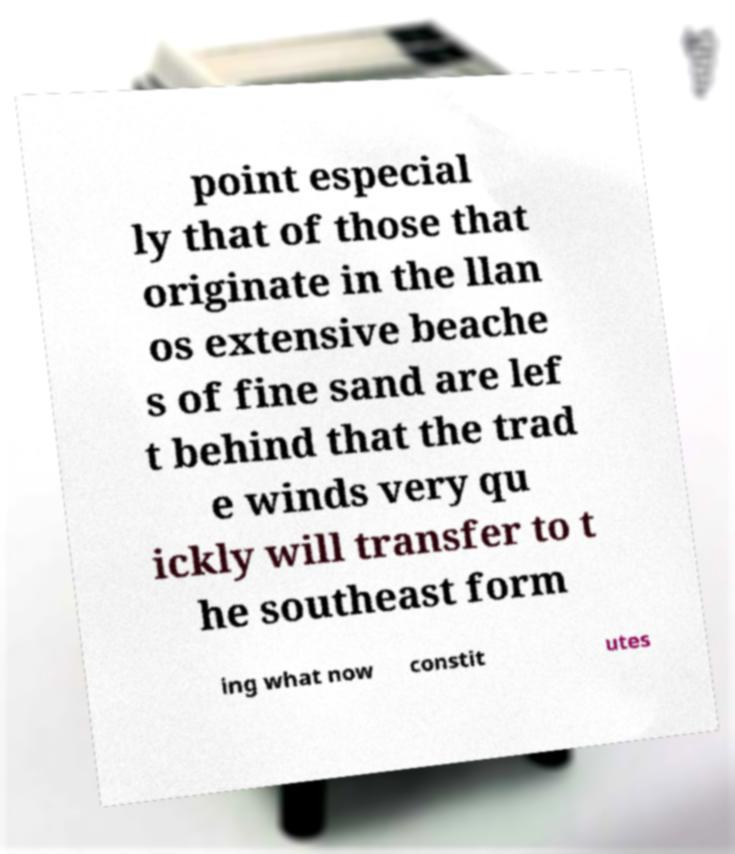I need the written content from this picture converted into text. Can you do that? point especial ly that of those that originate in the llan os extensive beache s of fine sand are lef t behind that the trad e winds very qu ickly will transfer to t he southeast form ing what now constit utes 